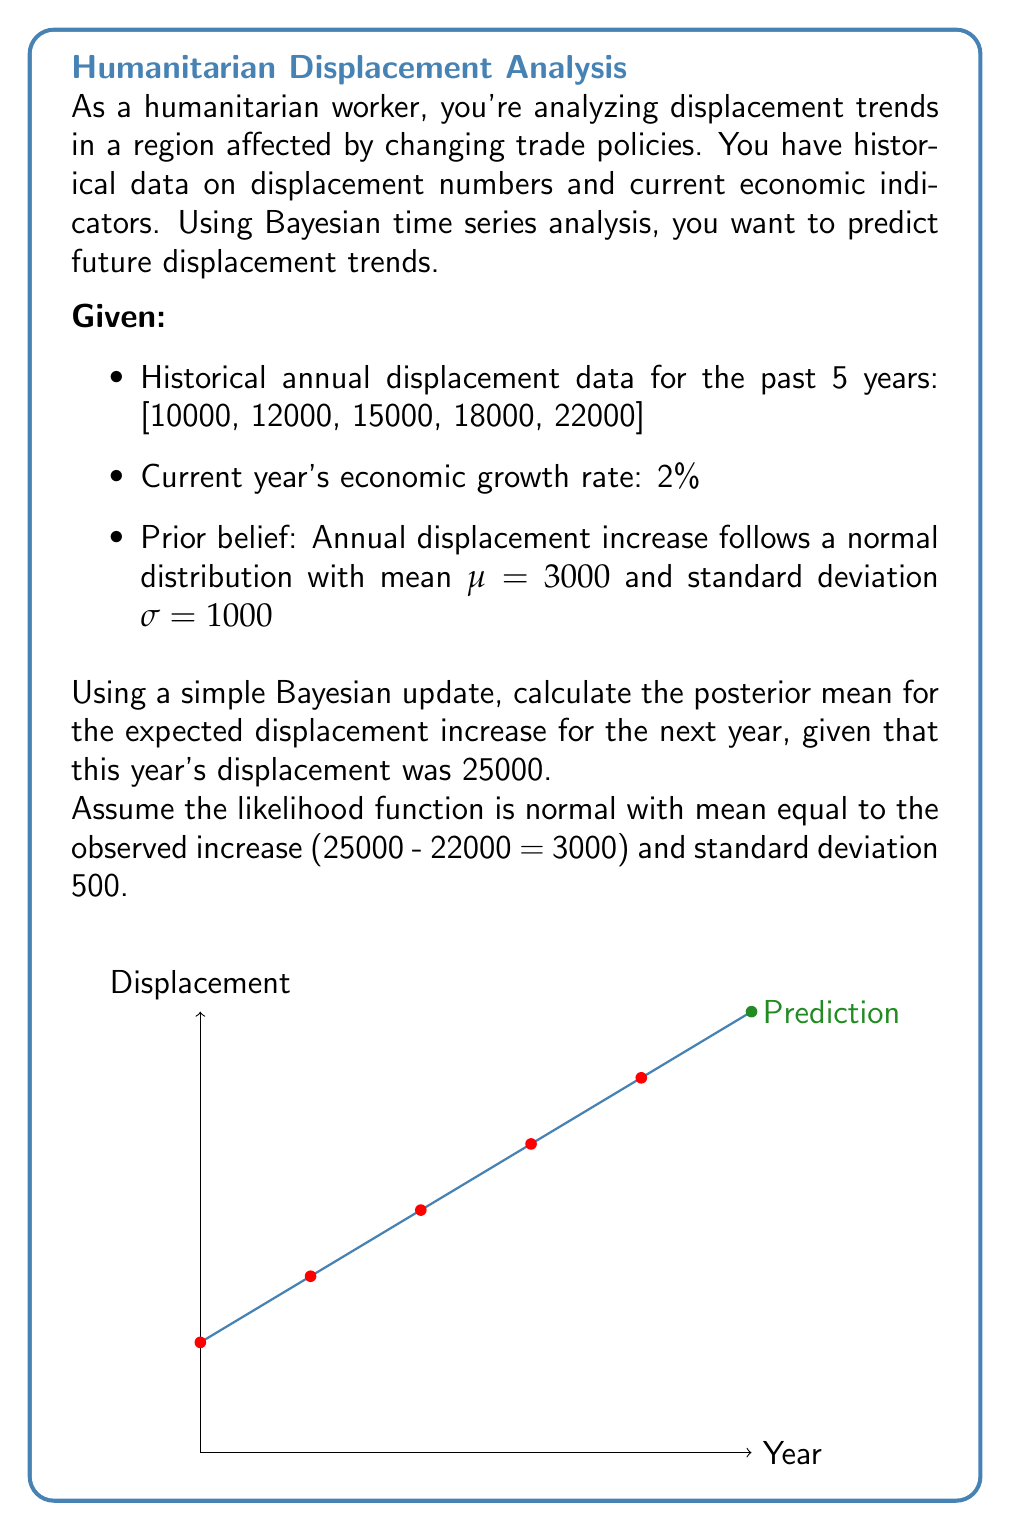Solve this math problem. To solve this problem using Bayesian updating, we'll follow these steps:

1) First, recall the formula for Bayesian updating with normal prior and normal likelihood:

   $$\mu_{posterior} = \frac{\frac{\mu_{prior}}{\sigma_{prior}^2} + \frac{x}{\sigma_{likelihood}^2}}{\frac{1}{\sigma_{prior}^2} + \frac{1}{\sigma_{likelihood}^2}}$$

   where $\mu_{prior}$ is the prior mean, $\sigma_{prior}$ is the prior standard deviation, $x$ is the observed value, and $\sigma_{likelihood}$ is the likelihood standard deviation.

2) We're given:
   - $\mu_{prior} = 3000$
   - $\sigma_{prior} = 1000$
   - $x = 3000$ (observed increase from 22000 to 25000)
   - $\sigma_{likelihood} = 500$

3) Let's substitute these values into our formula:

   $$\mu_{posterior} = \frac{\frac{3000}{1000^2} + \frac{3000}{500^2}}{\frac{1}{1000^2} + \frac{1}{500^2}}$$

4) Simplify:
   $$\mu_{posterior} = \frac{\frac{3000}{1000000} + \frac{3000}{250000}}{\frac{1}{1000000} + \frac{1}{250000}}$$
   
   $$= \frac{0.003 + 0.012}{0.000001 + 0.000004}$$
   
   $$= \frac{0.015}{0.000005}$$

5) Calculate the final result:
   $$\mu_{posterior} = 3000$$

Therefore, the posterior mean for the expected displacement increase for the next year is 3000.
Answer: 3000 